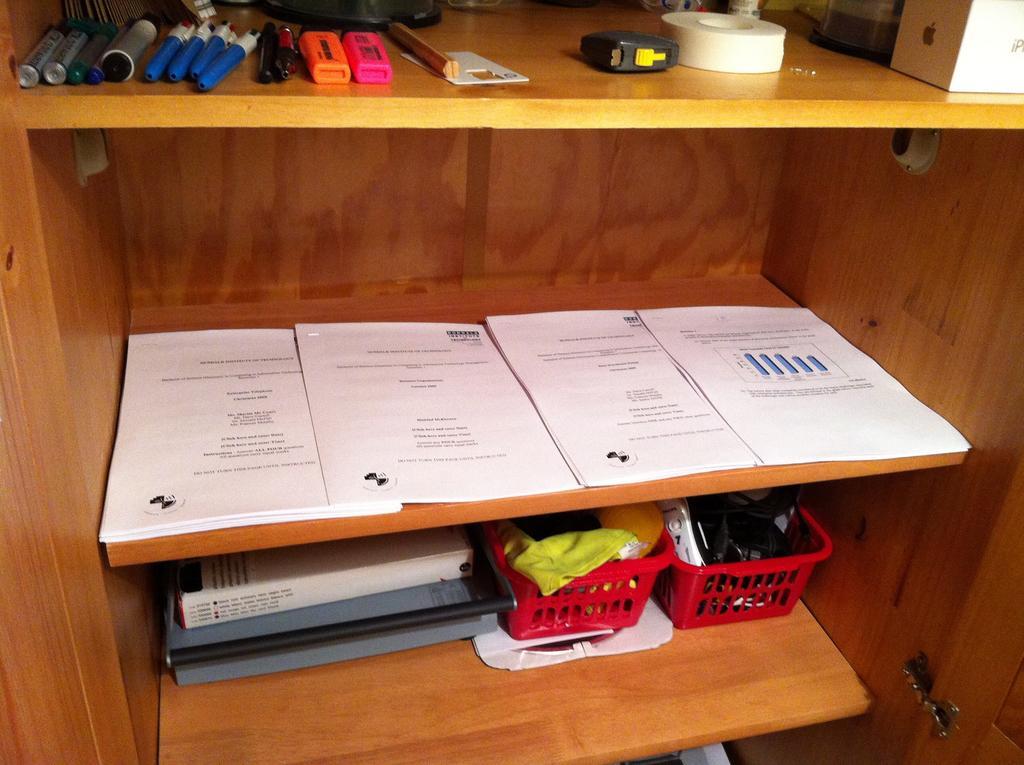Please provide a concise description of this image. In this image there is a shelf and we can see papers, files, baskets, markers, pens, tape and some objects placed in the shelves. 